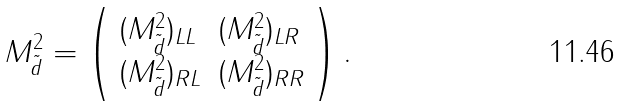Convert formula to latex. <formula><loc_0><loc_0><loc_500><loc_500>M _ { \tilde { d } } ^ { 2 } = \left ( \begin{array} { l l } { { ( M _ { \tilde { d } } ^ { 2 } ) _ { L L } } } & { { ( M _ { \tilde { d } } ^ { 2 } ) _ { L R } } } \\ { { ( M _ { \tilde { d } } ^ { 2 } ) _ { R L } } } & { { ( M _ { \tilde { d } } ^ { 2 } ) _ { R R } } } \end{array} \right ) .</formula> 